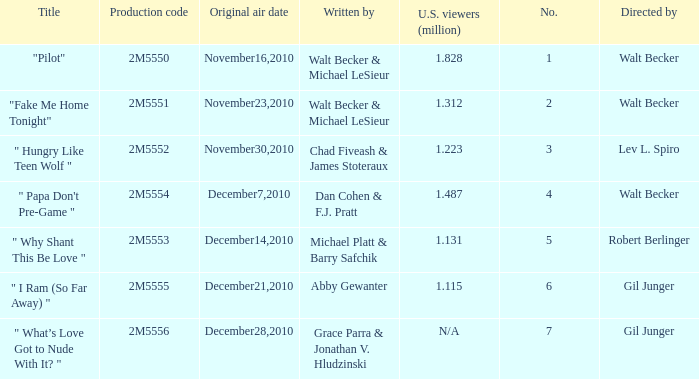How many million U.S. viewers saw "Fake Me Home Tonight"? 1.312. Parse the table in full. {'header': ['Title', 'Production code', 'Original air date', 'Written by', 'U.S. viewers (million)', 'No.', 'Directed by'], 'rows': [['"Pilot"', '2M5550', 'November16,2010', 'Walt Becker & Michael LeSieur', '1.828', '1', 'Walt Becker'], ['"Fake Me Home Tonight"', '2M5551', 'November23,2010', 'Walt Becker & Michael LeSieur', '1.312', '2', 'Walt Becker'], ['" Hungry Like Teen Wolf "', '2M5552', 'November30,2010', 'Chad Fiveash & James Stoteraux', '1.223', '3', 'Lev L. Spiro'], ['" Papa Don\'t Pre-Game "', '2M5554', 'December7,2010', 'Dan Cohen & F.J. Pratt', '1.487', '4', 'Walt Becker'], ['" Why Shant This Be Love "', '2M5553', 'December14,2010', 'Michael Platt & Barry Safchik', '1.131', '5', 'Robert Berlinger'], ['" I Ram (So Far Away) "', '2M5555', 'December21,2010', 'Abby Gewanter', '1.115', '6', 'Gil Junger'], ['" What’s Love Got to Nude With It? "', '2M5556', 'December28,2010', 'Grace Parra & Jonathan V. Hludzinski', 'N/A', '7', 'Gil Junger']]} 